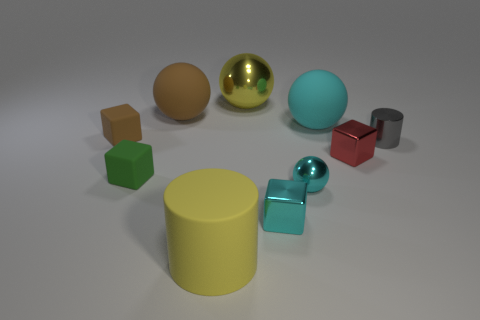Subtract all big brown rubber spheres. How many spheres are left? 3 Subtract all yellow blocks. How many cyan balls are left? 2 Subtract all brown blocks. How many blocks are left? 3 Subtract 1 blocks. How many blocks are left? 3 Subtract all cubes. How many objects are left? 6 Subtract all small brown metallic cylinders. Subtract all big brown matte objects. How many objects are left? 9 Add 7 cyan metallic things. How many cyan metallic things are left? 9 Add 5 big cyan matte blocks. How many big cyan matte blocks exist? 5 Subtract 0 blue cylinders. How many objects are left? 10 Subtract all blue blocks. Subtract all gray spheres. How many blocks are left? 4 